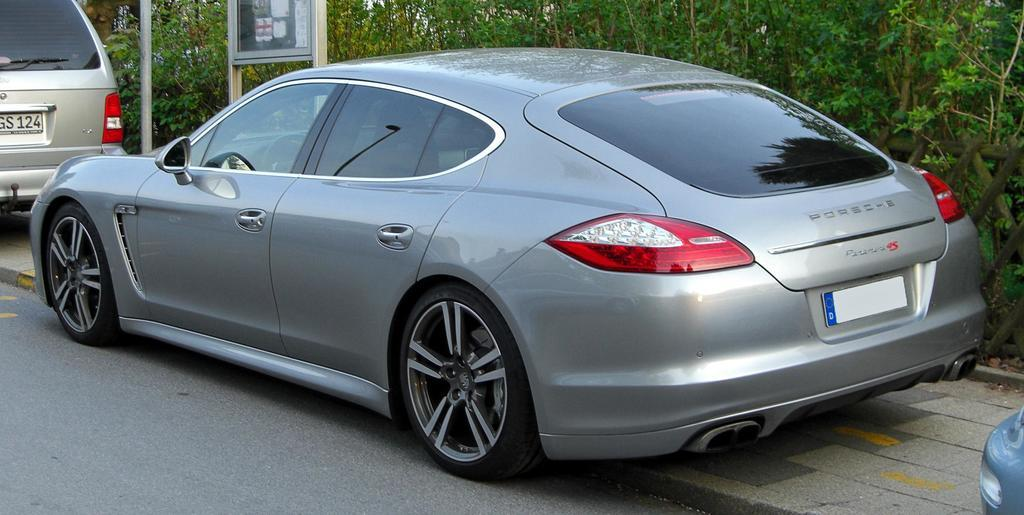What type of path is visible in the image? There is a road and a footpath in the image. What can be seen traveling on the road in the image? Vehicles are present in the image. What is the purpose of the board in the image? The purpose of the board in the image is not specified, but it could be for advertising or providing information. What is the pole in the image used for? The pole in the image could be used for supporting streetlights, traffic signals, or other infrastructure. What can be seen in the background of the image? Trees are visible in the background of the image. What type of blade is being used to take the picture in the image? There is no camera or blade present in the image; it is a still photograph of a scene. How many needles are visible on the pole in the image? There are no needles present on the pole in the image. 